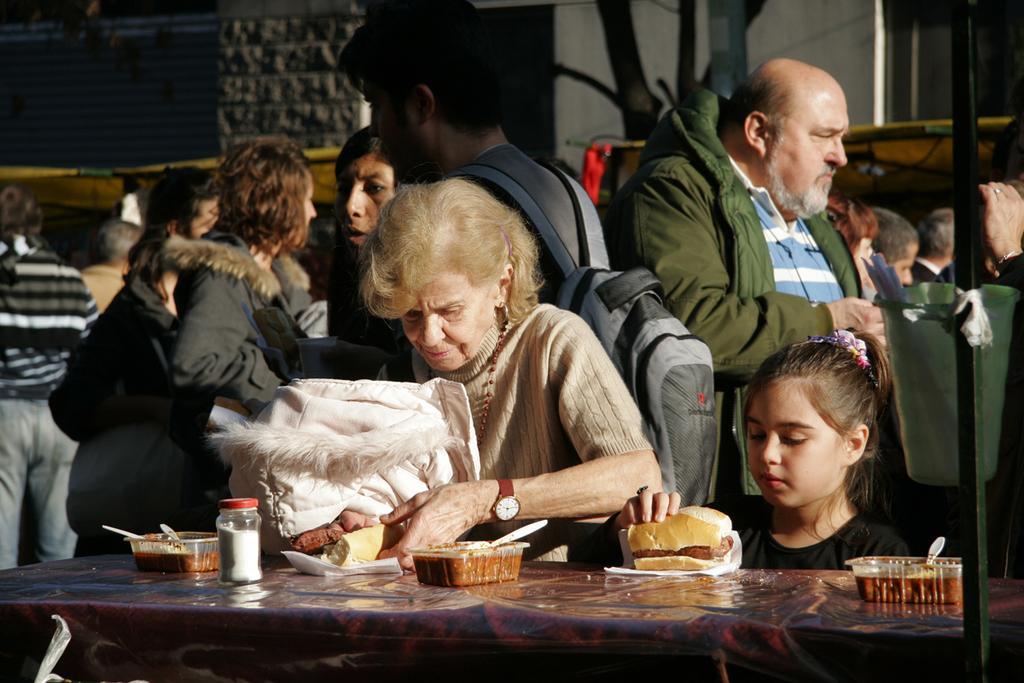Please provide a concise description of this image. Few persons standing. This person wear bag. this person holding cloth. This is table. On the table we can see box,food,spoon,jar. This person holding food. On the background we can see wall. This is wall. 